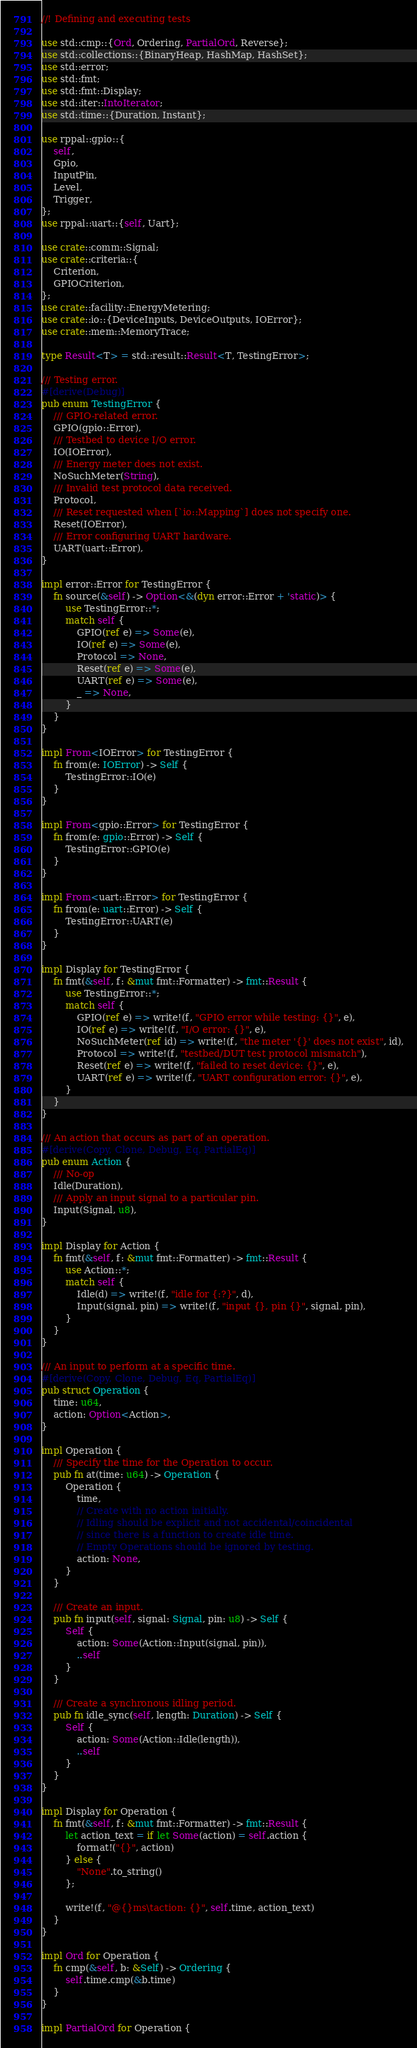<code> <loc_0><loc_0><loc_500><loc_500><_Rust_>//! Defining and executing tests

use std::cmp::{Ord, Ordering, PartialOrd, Reverse};
use std::collections::{BinaryHeap, HashMap, HashSet};
use std::error;
use std::fmt;
use std::fmt::Display;
use std::iter::IntoIterator;
use std::time::{Duration, Instant};

use rppal::gpio::{
    self,
    Gpio,
    InputPin,
    Level,
    Trigger,
};
use rppal::uart::{self, Uart};

use crate::comm::Signal;
use crate::criteria::{
    Criterion,
    GPIOCriterion,
};
use crate::facility::EnergyMetering;
use crate::io::{DeviceInputs, DeviceOutputs, IOError};
use crate::mem::MemoryTrace;

type Result<T> = std::result::Result<T, TestingError>;

/// Testing error.
#[derive(Debug)]
pub enum TestingError {
    /// GPIO-related error.
    GPIO(gpio::Error),
    /// Testbed to device I/O error.
    IO(IOError),
    /// Energy meter does not exist.
    NoSuchMeter(String),
    /// Invalid test protocol data received.
    Protocol,
    /// Reset requested when [`io::Mapping`] does not specify one.
    Reset(IOError),
    /// Error configuring UART hardware.
    UART(uart::Error),
}

impl error::Error for TestingError {
    fn source(&self) -> Option<&(dyn error::Error + 'static)> {
        use TestingError::*;
        match self {
            GPIO(ref e) => Some(e),
            IO(ref e) => Some(e),
            Protocol => None,
            Reset(ref e) => Some(e),
            UART(ref e) => Some(e),
            _ => None,
        }
    }
}

impl From<IOError> for TestingError {
    fn from(e: IOError) -> Self {
        TestingError::IO(e)
    }
}

impl From<gpio::Error> for TestingError {
    fn from(e: gpio::Error) -> Self {
        TestingError::GPIO(e)
    }
}

impl From<uart::Error> for TestingError {
    fn from(e: uart::Error) -> Self {
        TestingError::UART(e)
    }
}

impl Display for TestingError {
    fn fmt(&self, f: &mut fmt::Formatter) -> fmt::Result {
        use TestingError::*;
        match self {
            GPIO(ref e) => write!(f, "GPIO error while testing: {}", e),
            IO(ref e) => write!(f, "I/O error: {}", e),
            NoSuchMeter(ref id) => write!(f, "the meter '{}' does not exist", id),
            Protocol => write!(f, "testbed/DUT test protocol mismatch"),
            Reset(ref e) => write!(f, "failed to reset device: {}", e),
            UART(ref e) => write!(f, "UART configuration error: {}", e),
        }
    }
}

/// An action that occurs as part of an operation.
#[derive(Copy, Clone, Debug, Eq, PartialEq)]
pub enum Action {
    /// No-op
    Idle(Duration),
    /// Apply an input signal to a particular pin.
    Input(Signal, u8),
}

impl Display for Action {
    fn fmt(&self, f: &mut fmt::Formatter) -> fmt::Result {
        use Action::*;
        match self {
            Idle(d) => write!(f, "idle for {:?}", d),
            Input(signal, pin) => write!(f, "input {}, pin {}", signal, pin),
        }
    }
}

/// An input to perform at a specific time.
#[derive(Copy, Clone, Debug, Eq, PartialEq)]
pub struct Operation {
    time: u64,
    action: Option<Action>,
}

impl Operation {
    /// Specify the time for the Operation to occur.
    pub fn at(time: u64) -> Operation {
        Operation {
            time,
            // Create with no action initially.
            // Idling should be explicit and not accidental/coincidental
            // since there is a function to create idle time.
            // Empty Operations should be ignored by testing.
            action: None,
        }
    }

    /// Create an input.
    pub fn input(self, signal: Signal, pin: u8) -> Self {
        Self {
            action: Some(Action::Input(signal, pin)),
            ..self
        }
    }

    /// Create a synchronous idling period.
    pub fn idle_sync(self, length: Duration) -> Self {
        Self {
            action: Some(Action::Idle(length)),
            ..self
        }
    }
}

impl Display for Operation {
    fn fmt(&self, f: &mut fmt::Formatter) -> fmt::Result {
        let action_text = if let Some(action) = self.action {
            format!("{}", action)
        } else {
            "None".to_string()
        };

        write!(f, "@{}ms\taction: {}", self.time, action_text)
    }
}

impl Ord for Operation {
    fn cmp(&self, b: &Self) -> Ordering {
        self.time.cmp(&b.time)
    }
}

impl PartialOrd for Operation {</code> 